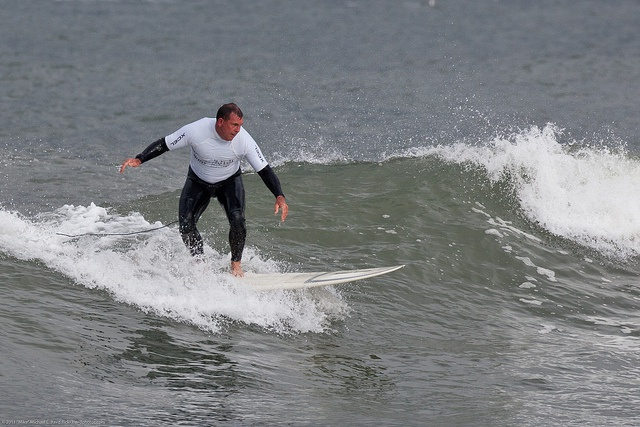Describe the objects in this image and their specific colors. I can see people in gray, black, darkgray, and lavender tones and surfboard in gray, lightgray, and darkgray tones in this image. 